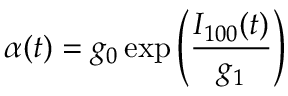Convert formula to latex. <formula><loc_0><loc_0><loc_500><loc_500>\alpha ( t ) = g _ { 0 } \exp \left ( \frac { I _ { 1 0 0 } ( t ) } { g _ { 1 } } \right )</formula> 